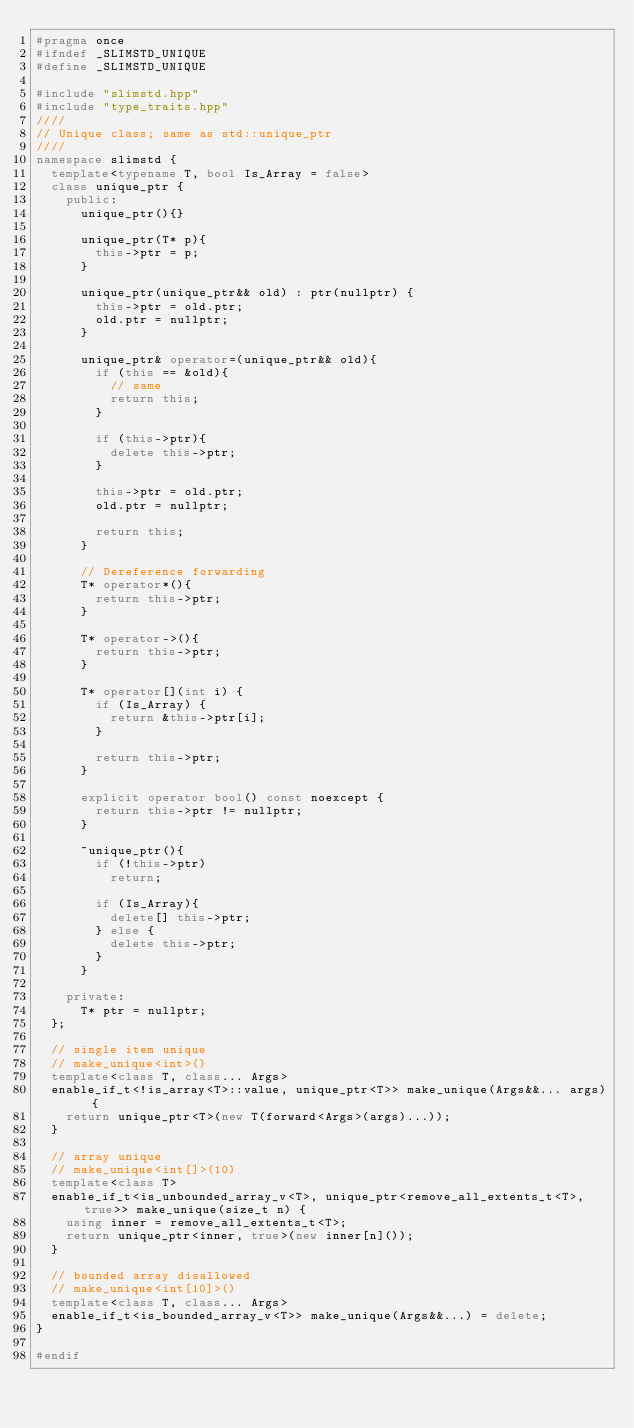<code> <loc_0><loc_0><loc_500><loc_500><_C++_>#pragma once
#ifndef _SLIMSTD_UNIQUE
#define _SLIMSTD_UNIQUE

#include "slimstd.hpp"
#include "type_traits.hpp"
////
// Unique class; same as std::unique_ptr
////
namespace slimstd {
  template<typename T, bool Is_Array = false>
  class unique_ptr {
    public:
      unique_ptr(){}

      unique_ptr(T* p){
        this->ptr = p;
      }

      unique_ptr(unique_ptr&& old) : ptr(nullptr) {
        this->ptr = old.ptr;
        old.ptr = nullptr;
      }

      unique_ptr& operator=(unique_ptr&& old){
        if (this == &old){
          // same
          return this;
        }

        if (this->ptr){
          delete this->ptr;
        }

        this->ptr = old.ptr;
        old.ptr = nullptr;

        return this;
      }

      // Dereference forwarding
      T* operator*(){
        return this->ptr;
      }

      T* operator->(){
        return this->ptr;
      }

      T* operator[](int i) {
        if (Is_Array) {
          return &this->ptr[i];
        } 

        return this->ptr;
      }

      explicit operator bool() const noexcept {
        return this->ptr != nullptr;
      }

      ~unique_ptr(){
        if (!this->ptr)
          return;

        if (Is_Array){
          delete[] this->ptr;
        } else {
          delete this->ptr;
        }
      }

    private:
      T* ptr = nullptr;
  };

  // single item unique
  // make_unique<int>()
  template<class T, class... Args>
  enable_if_t<!is_array<T>::value, unique_ptr<T>> make_unique(Args&&... args) {
    return unique_ptr<T>(new T(forward<Args>(args)...));
  }

  // array unique
  // make_unique<int[]>(10)
  template<class T>
  enable_if_t<is_unbounded_array_v<T>, unique_ptr<remove_all_extents_t<T>, true>> make_unique(size_t n) {
    using inner = remove_all_extents_t<T>;
    return unique_ptr<inner, true>(new inner[n]());
  }

  // bounded array disallowed
  // make_unique<int[10]>()
  template<class T, class... Args>
  enable_if_t<is_bounded_array_v<T>> make_unique(Args&&...) = delete;
}

#endif
</code> 